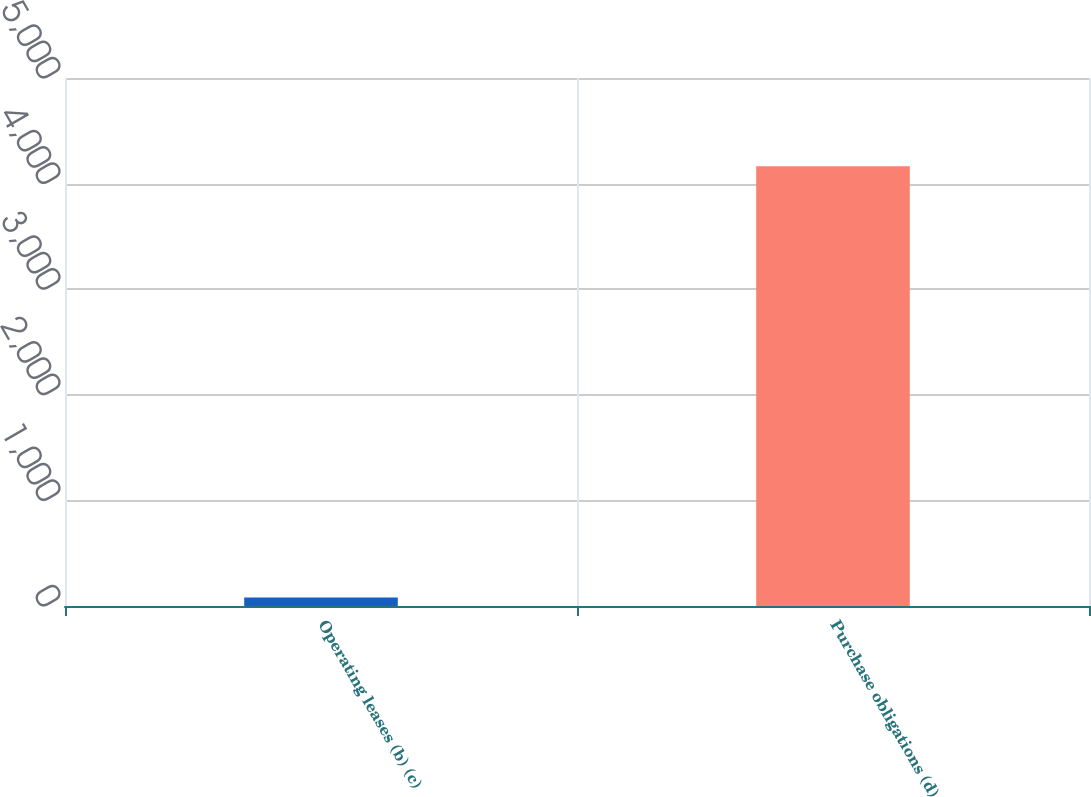<chart> <loc_0><loc_0><loc_500><loc_500><bar_chart><fcel>Operating leases (b) (c)<fcel>Purchase obligations (d)<nl><fcel>80<fcel>4165<nl></chart> 